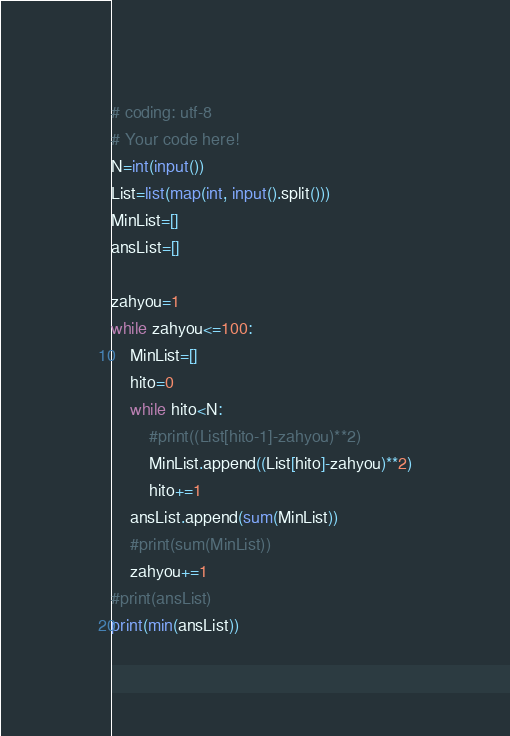<code> <loc_0><loc_0><loc_500><loc_500><_Python_># coding: utf-8
# Your code here!
N=int(input())
List=list(map(int, input().split()))
MinList=[]
ansList=[]

zahyou=1
while zahyou<=100:
    MinList=[]
    hito=0
    while hito<N:
        #print((List[hito-1]-zahyou)**2)
        MinList.append((List[hito]-zahyou)**2)
        hito+=1
    ansList.append(sum(MinList))
    #print(sum(MinList))
    zahyou+=1
#print(ansList)
print(min(ansList))</code> 